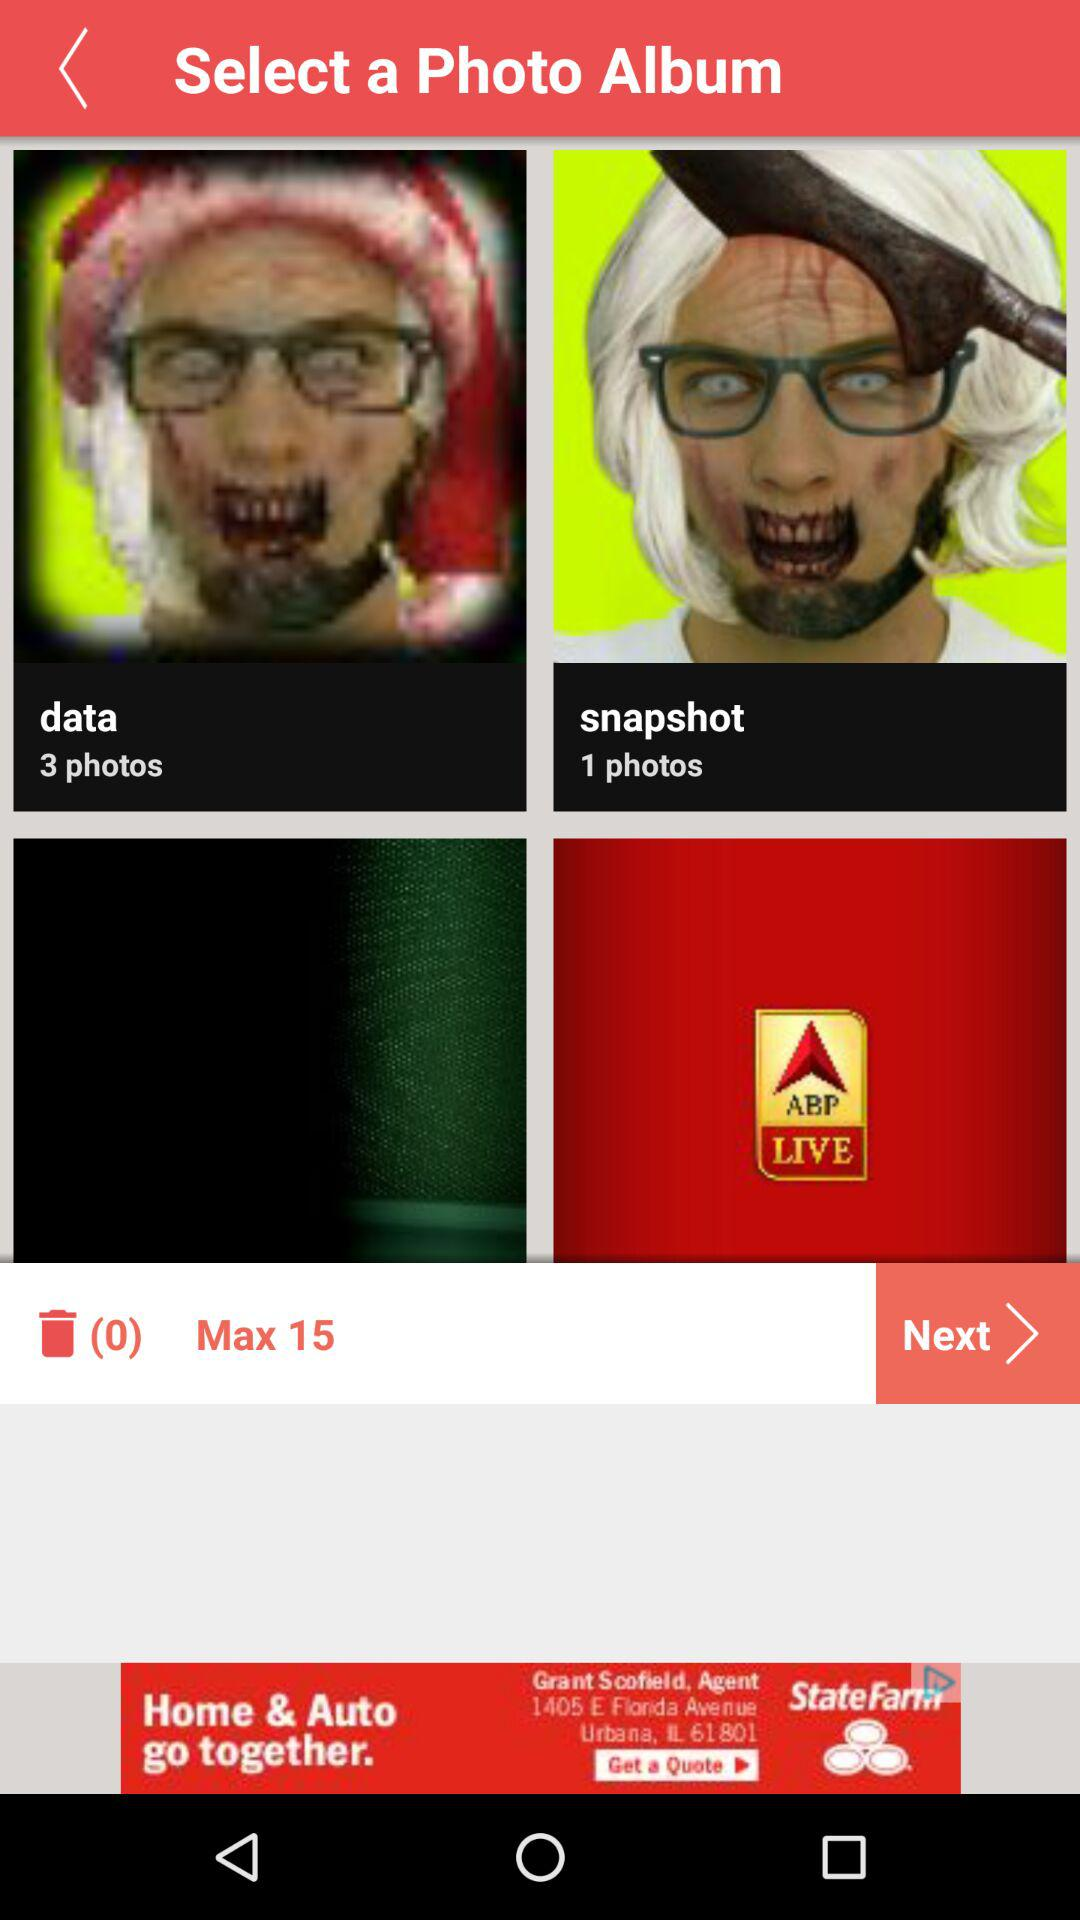How many photos are there in "data"? There are 3 photos in "data". 